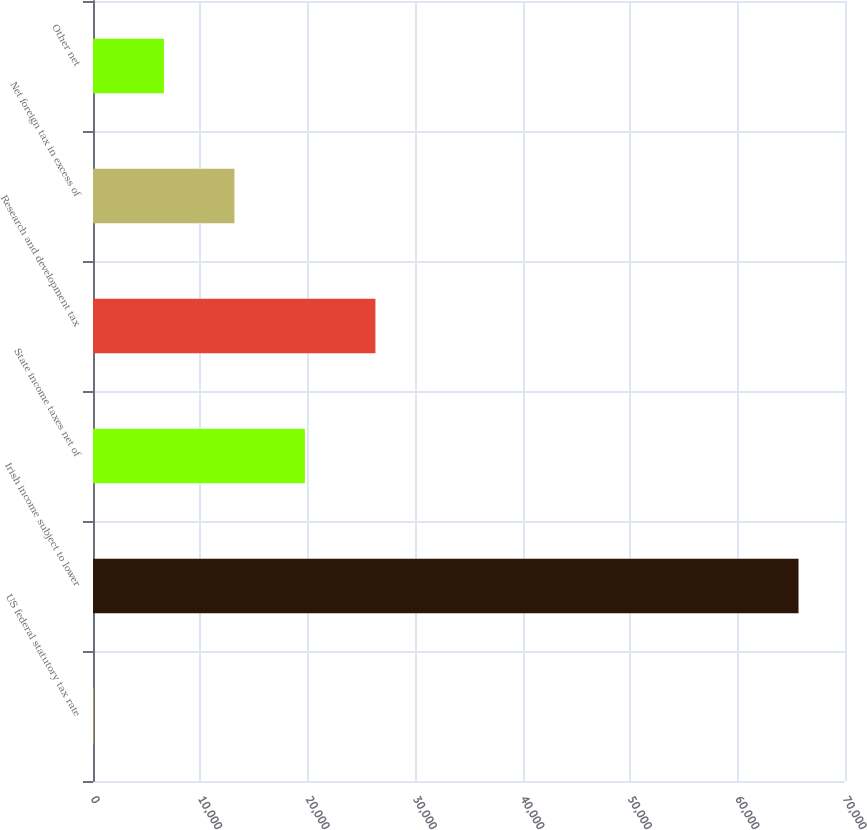<chart> <loc_0><loc_0><loc_500><loc_500><bar_chart><fcel>US federal statutory tax rate<fcel>Irish income subject to lower<fcel>State income taxes net of<fcel>Research and development tax<fcel>Net foreign tax in excess of<fcel>Other net<nl><fcel>35<fcel>65673<fcel>19726.4<fcel>26290.2<fcel>13162.6<fcel>6598.8<nl></chart> 